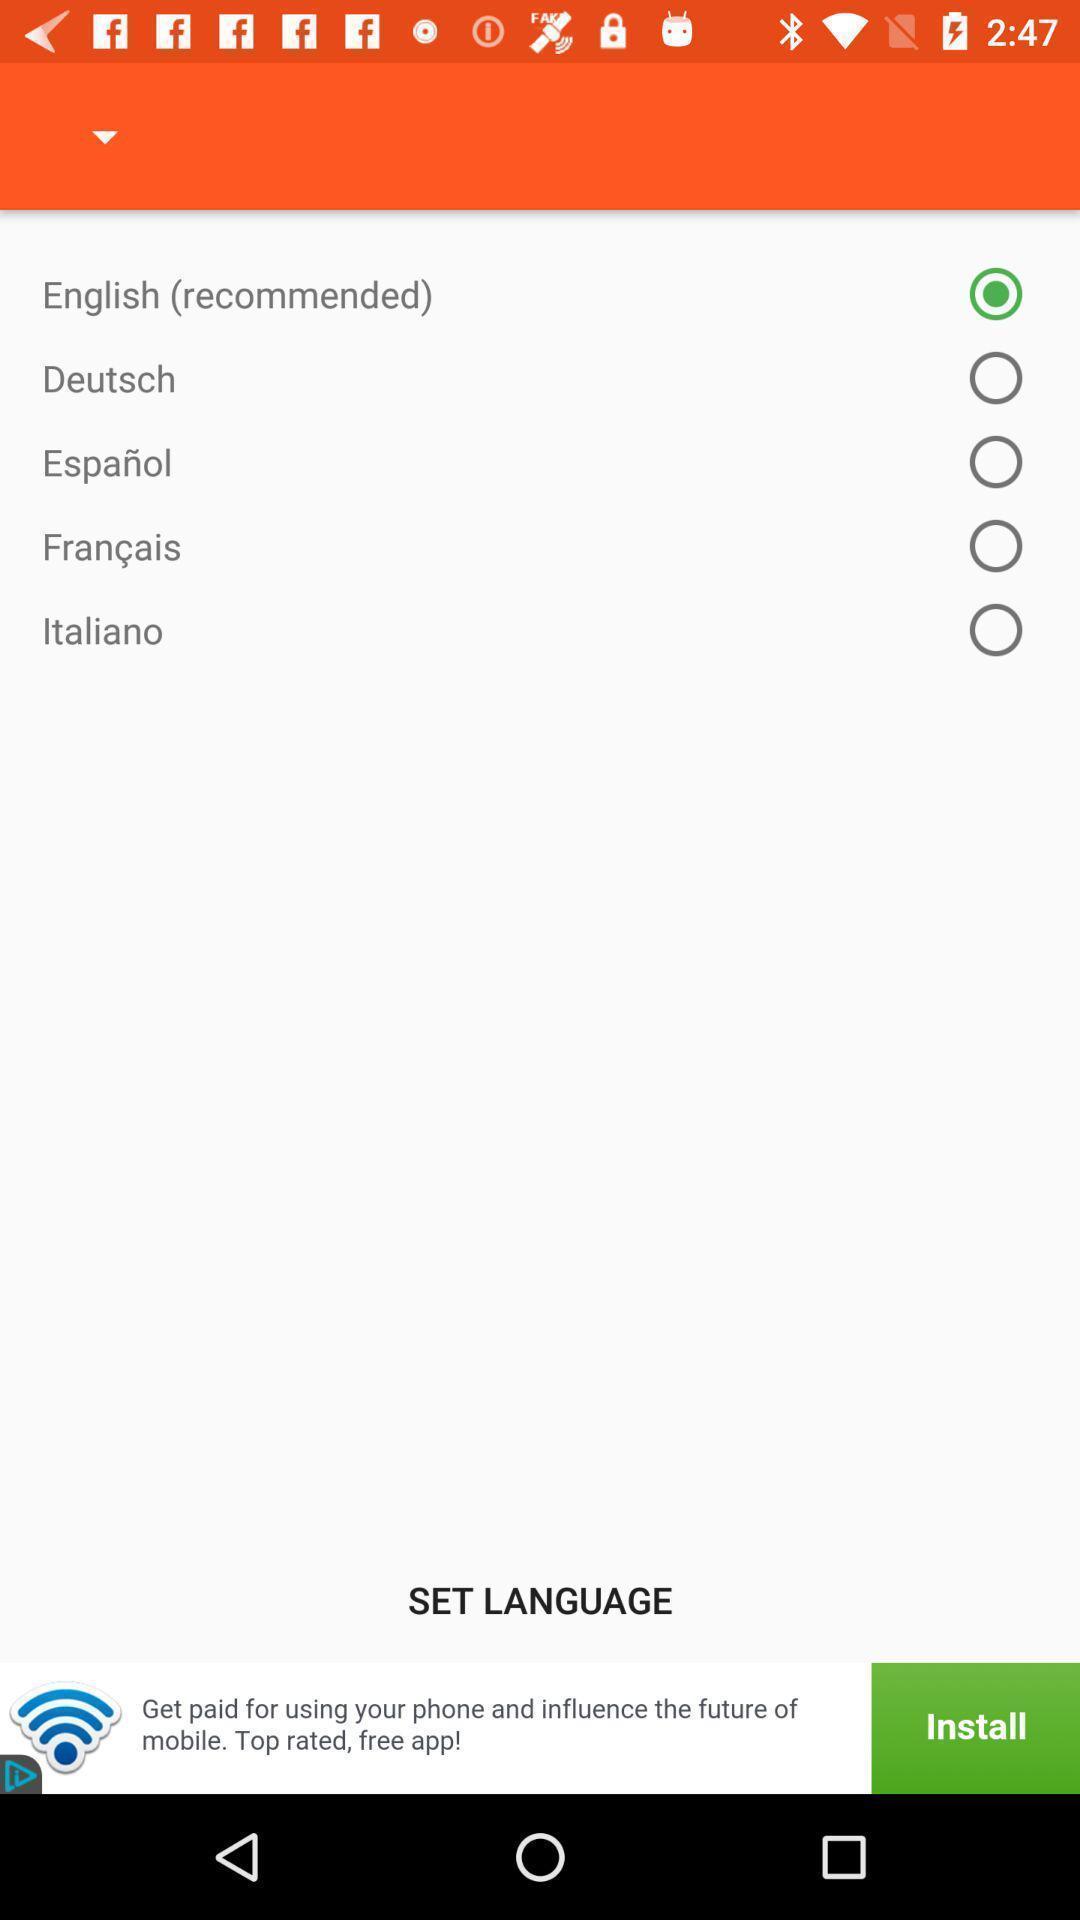Describe this image in words. Page displaying selected language option. 